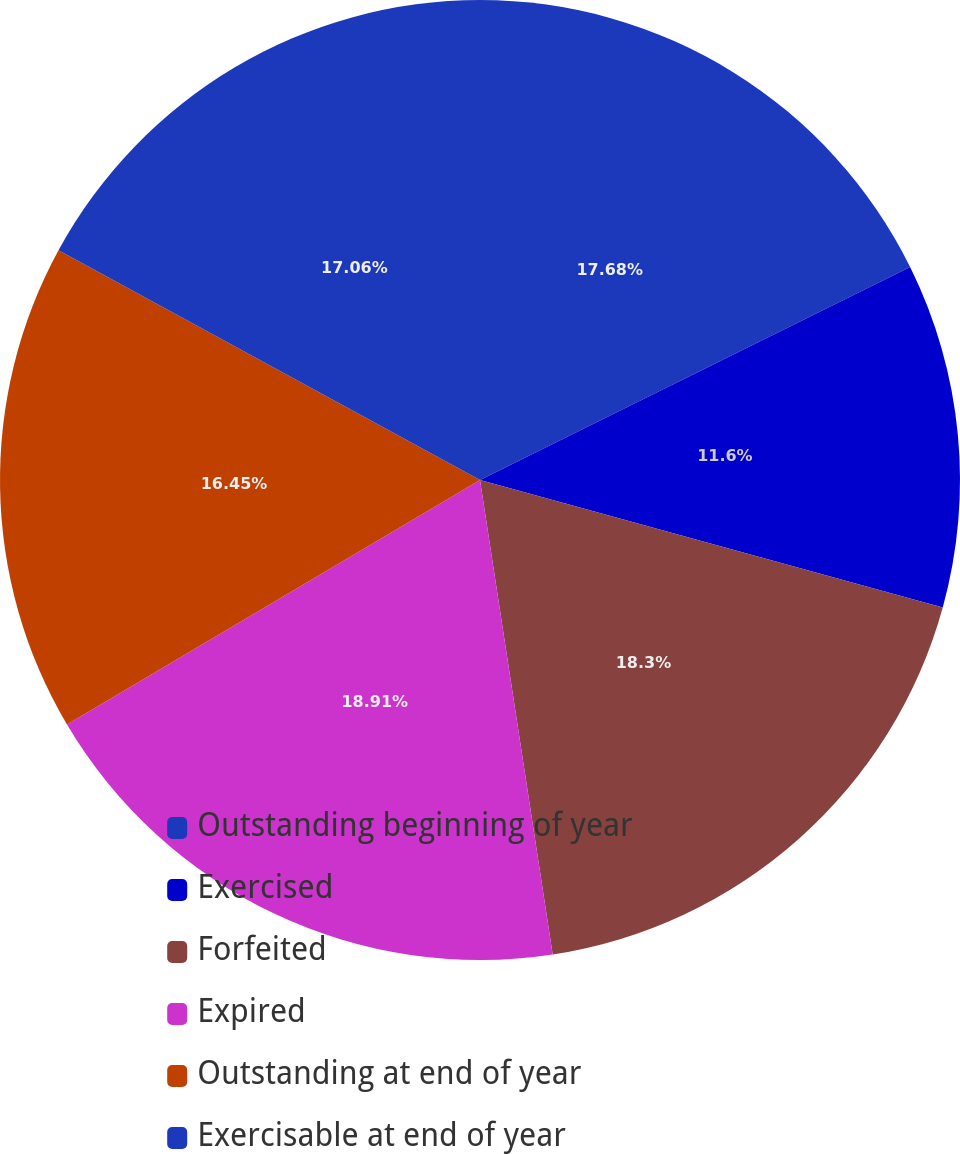Convert chart to OTSL. <chart><loc_0><loc_0><loc_500><loc_500><pie_chart><fcel>Outstanding beginning of year<fcel>Exercised<fcel>Forfeited<fcel>Expired<fcel>Outstanding at end of year<fcel>Exercisable at end of year<nl><fcel>17.68%<fcel>11.6%<fcel>18.3%<fcel>18.91%<fcel>16.45%<fcel>17.06%<nl></chart> 